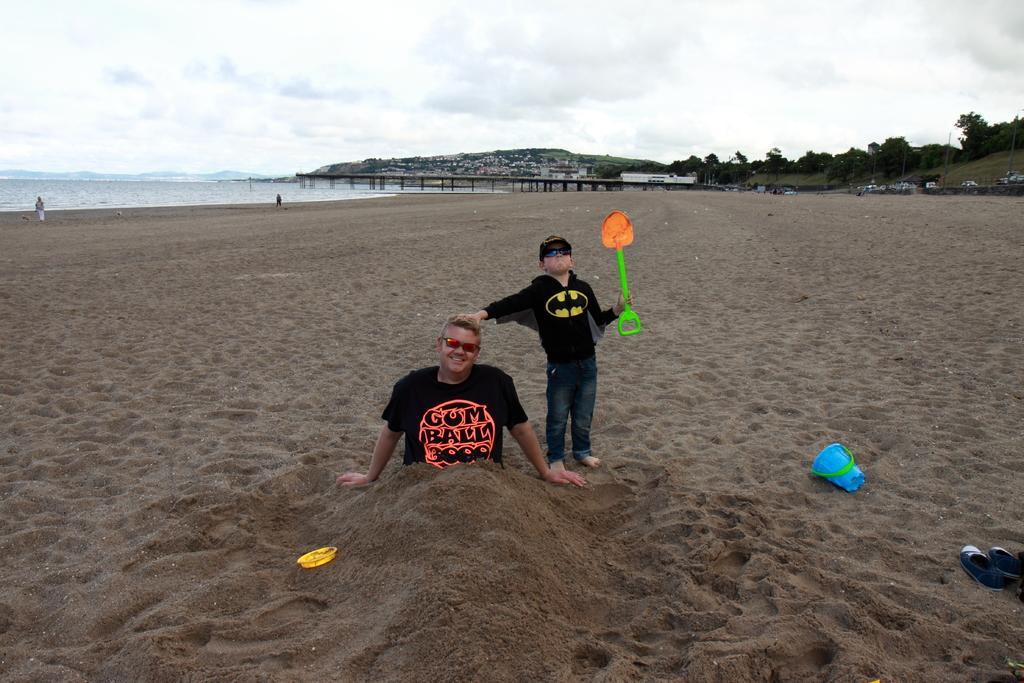In one or two sentences, can you explain what this image depicts? In this image in the middle there is a man, he wears a t shirt, on him there is sand and there is a boy, he wears a t shirt, trouser, he is holding a stick. On the right there are shoes, bucket. At the bottom there is sand. In the background there are some people, bridgewater, hills, trees, sky and clouds. 